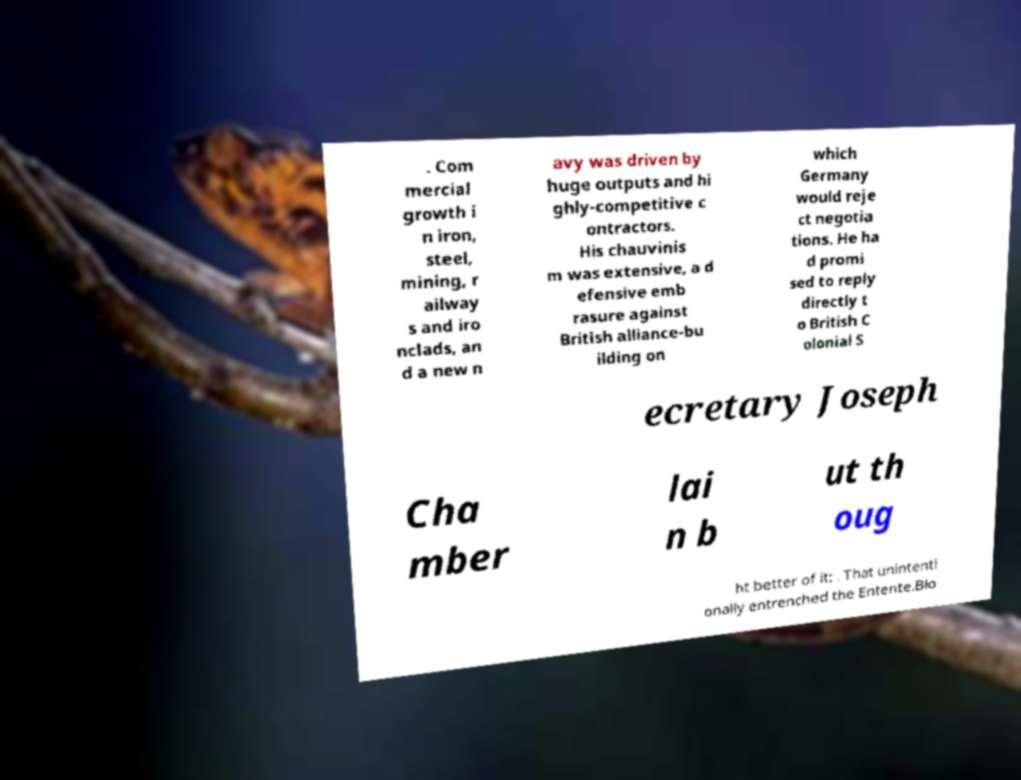For documentation purposes, I need the text within this image transcribed. Could you provide that? . Com mercial growth i n iron, steel, mining, r ailway s and iro nclads, an d a new n avy was driven by huge outputs and hi ghly-competitive c ontractors. His chauvinis m was extensive, a d efensive emb rasure against British alliance-bu ilding on which Germany would reje ct negotia tions. He ha d promi sed to reply directly t o British C olonial S ecretary Joseph Cha mber lai n b ut th oug ht better of it: . That unintenti onally entrenched the Entente.Blo 